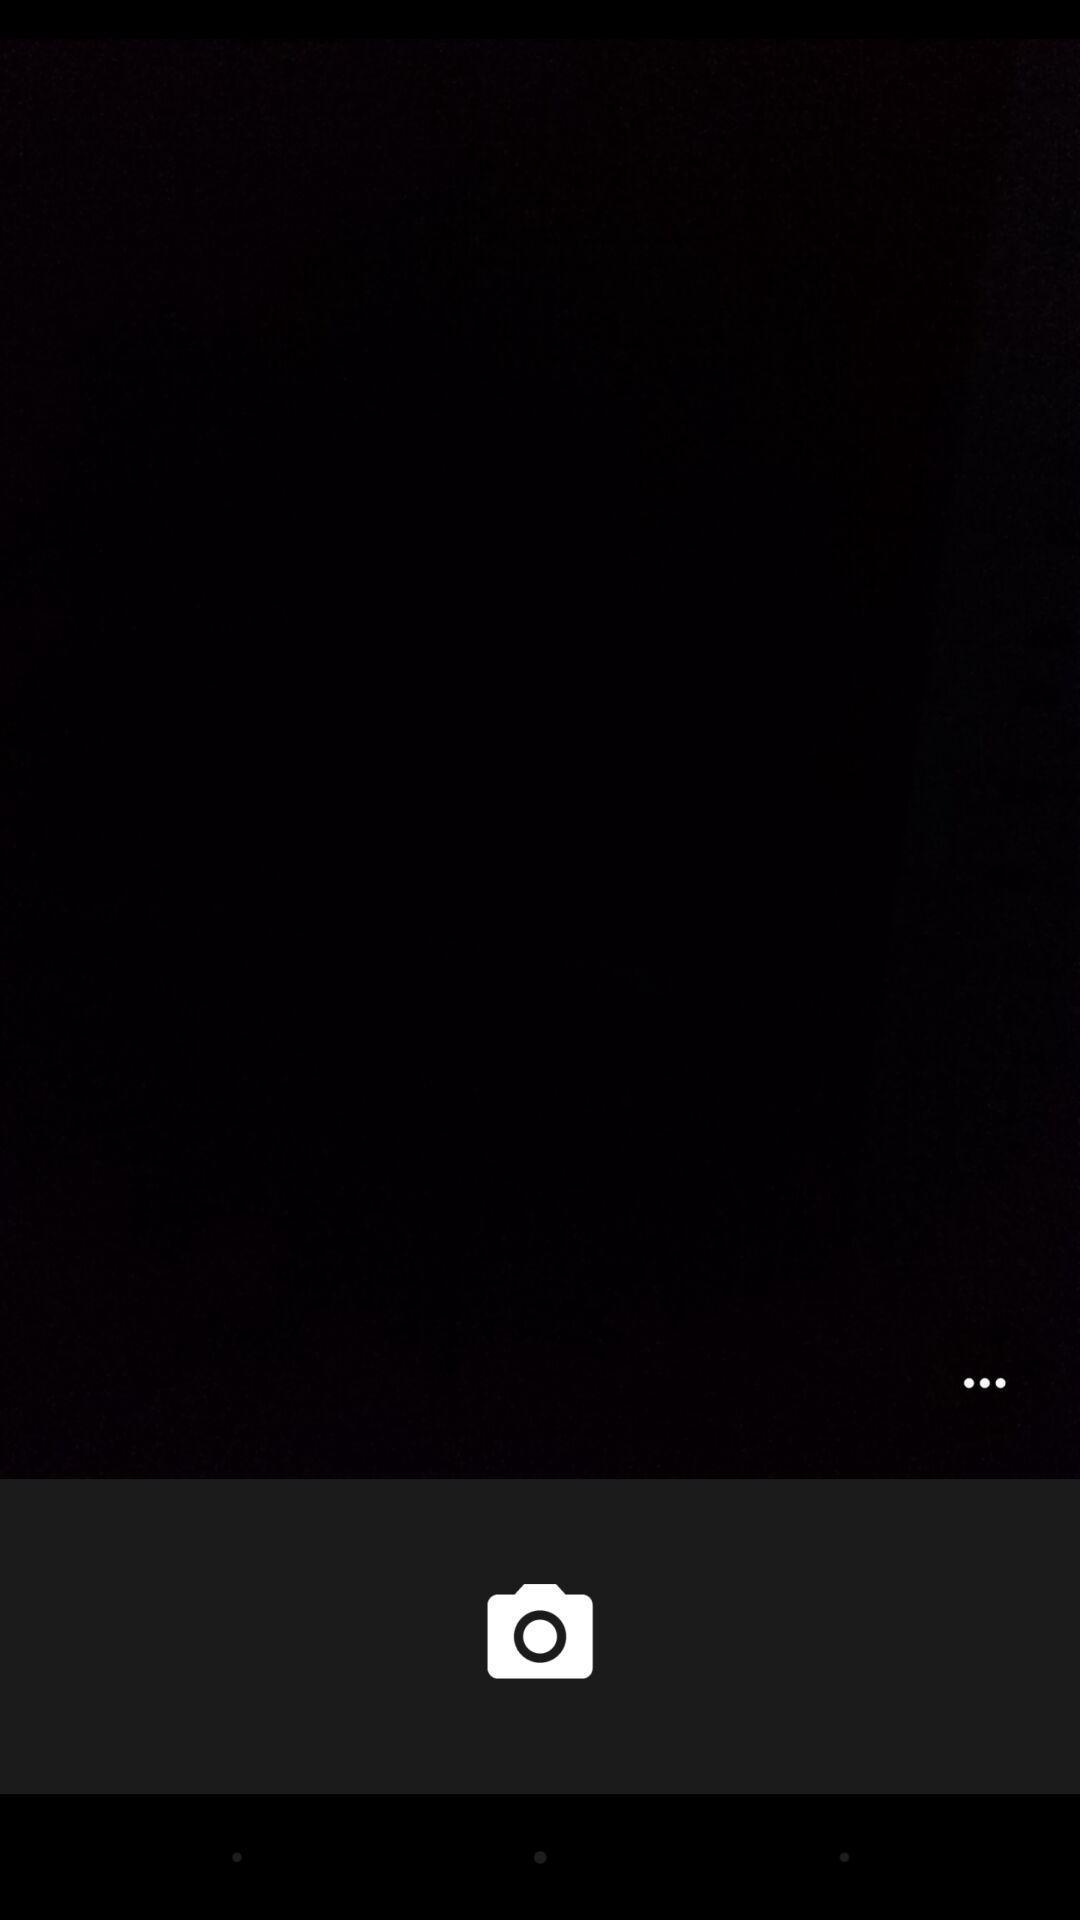Give me a narrative description of this picture. Screen showing the blank page in camera app. 